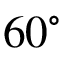<formula> <loc_0><loc_0><loc_500><loc_500>{ { 6 0 } ^ { \circ } }</formula> 